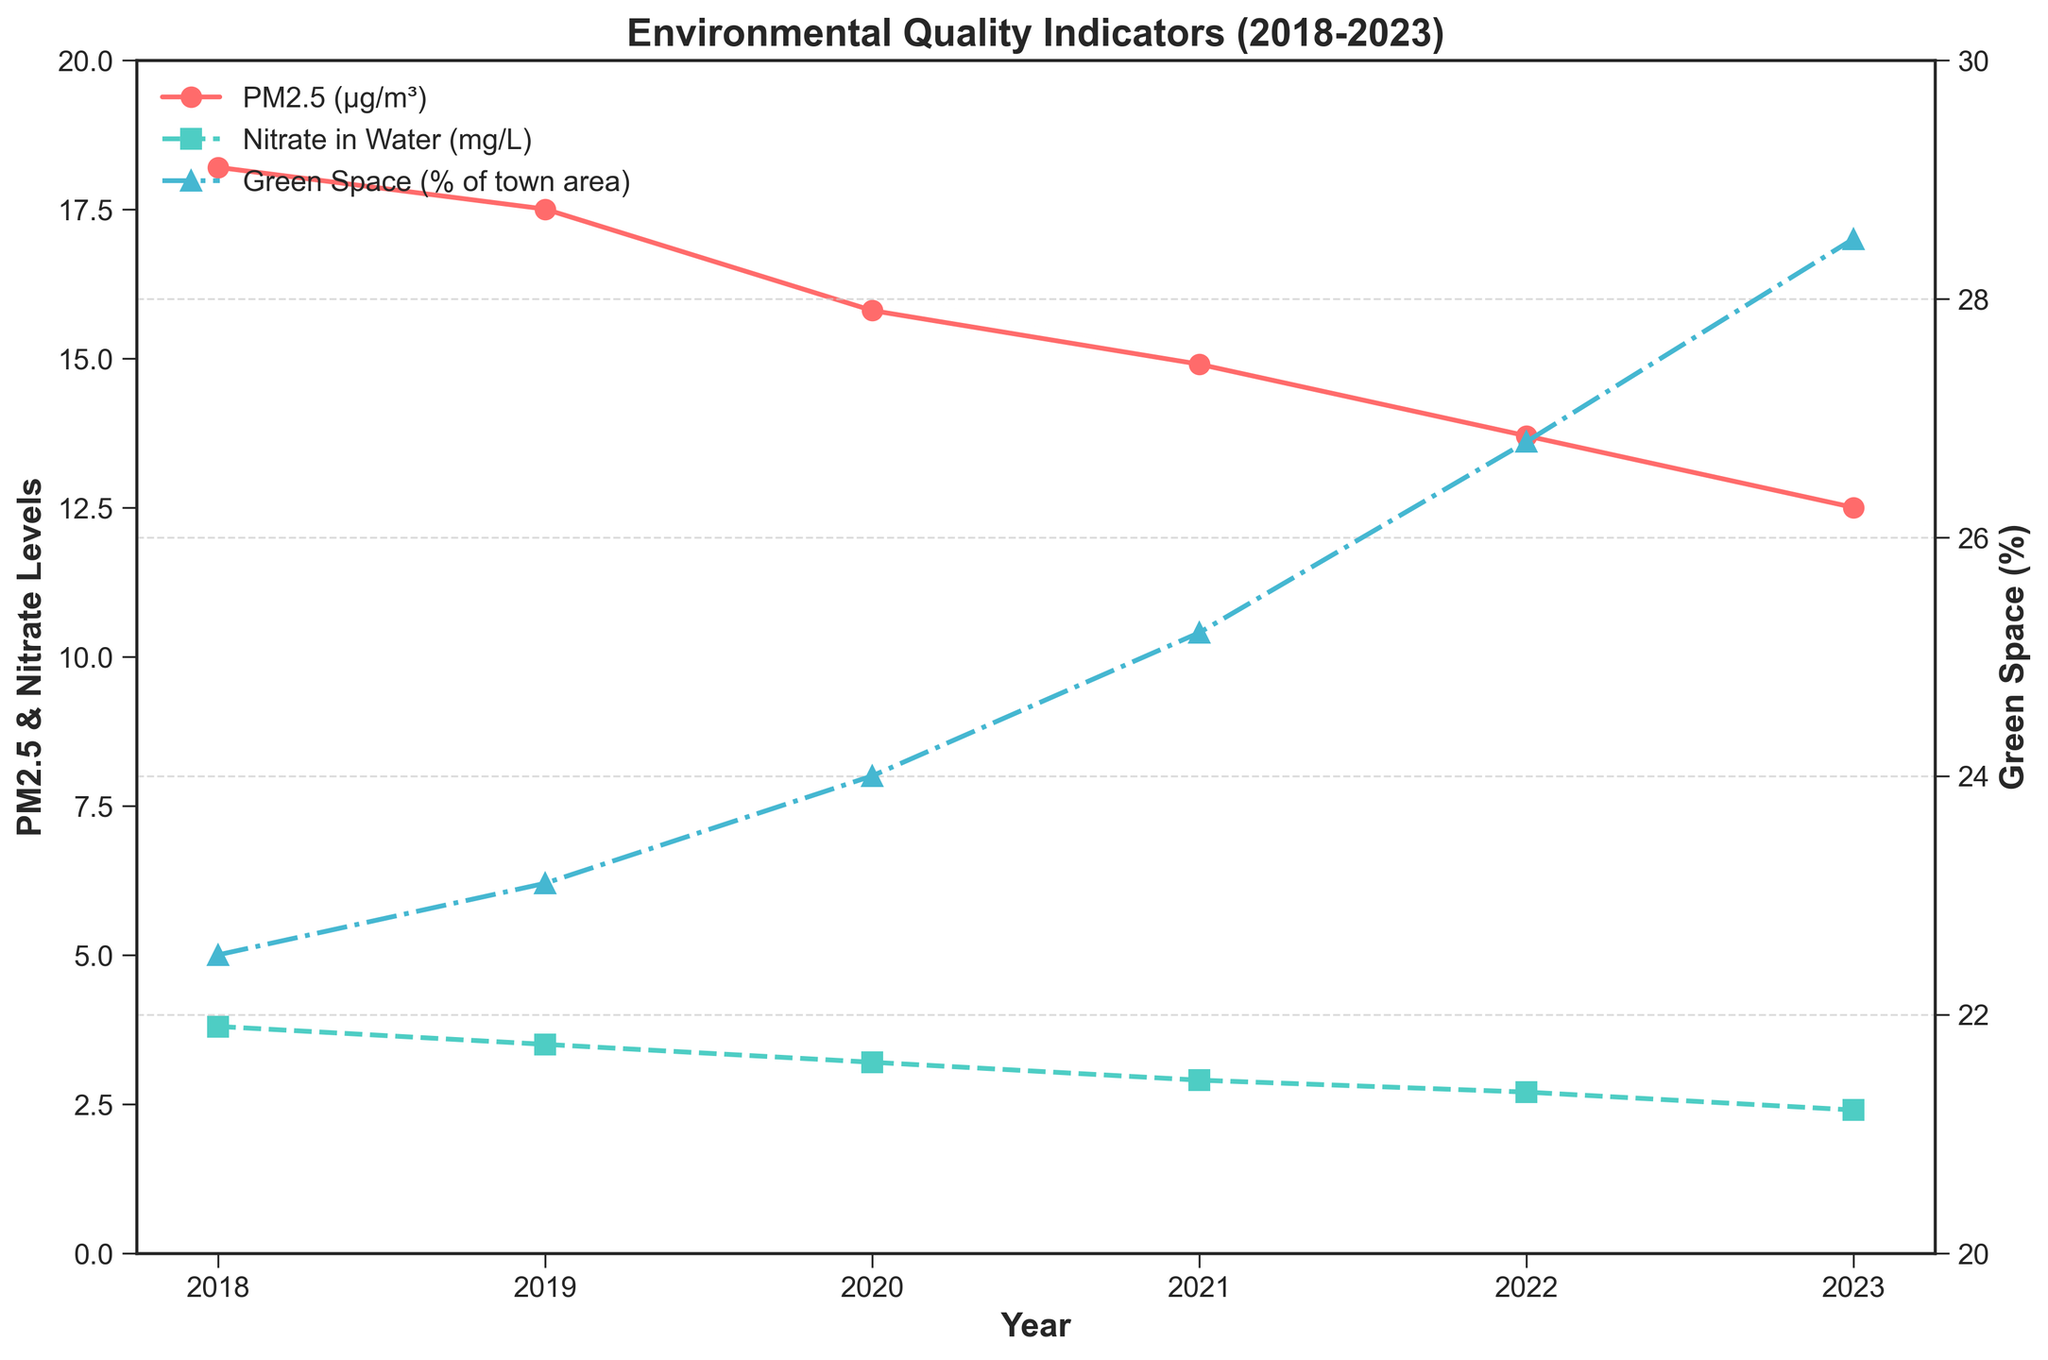What was the PM2.5 level in 2020? Look for the 2020 data point on the line representing PM2.5 levels, which is marked by red circles.
Answer: 15.8 µg/m³ How much did the nitrate levels in water decrease from 2018 to 2023? Find the nitrate levels for 2018 (3.8 mg/L) and 2023 (2.4 mg/L) on the line representing nitrate levels, marked by green squares, then subtract the value of 2023 from 2018.
Answer: Decreased by 1.4 mg/L What trend do we observe in green space percentage over the years? Observe the line representing the green space percentage, marked by blue triangles, and note the increase from 22.5% in 2018 to 28.5% in 2023.
Answer: Increasing trend In which year did PM2.5 levels drop below 16 µg/m³ for the first time? Track the PM2.5 levels over the years to find when the values dropped below 16 µg/m³, marked by red circles.
Answer: 2020 How much did green space as a percentage of town area increase from 2020 to 2023? Identify the green space percentage values for 2020 (24.0%) and 2023 (28.5%) on the blue triangles line, then subtract the 2020 value from the 2023 value.
Answer: Increased by 4.5% Which year saw the largest single-year decrease in PM2.5 levels? Observe the differences between consecutive years' PM2.5 levels, marked by red circles, and identify the year with the largest decrease. The largest drop is from 2021 to 2022 (14.9 to 13.7 µg/m³).
Answer: 2022 Compare the change in nitrate levels from 2018 to 2021 with the change from 2021 to 2023. Calculate the decrease from 2018 to 2021 (3.8 mg/L to 2.9 mg/L) and 2021 to 2023 (2.9 mg/L to 2.4 mg/L). The changes are 0.9 mg/L and 0.5 mg/L, respectively.
Answer: Larger decrease from 2018 to 2021 